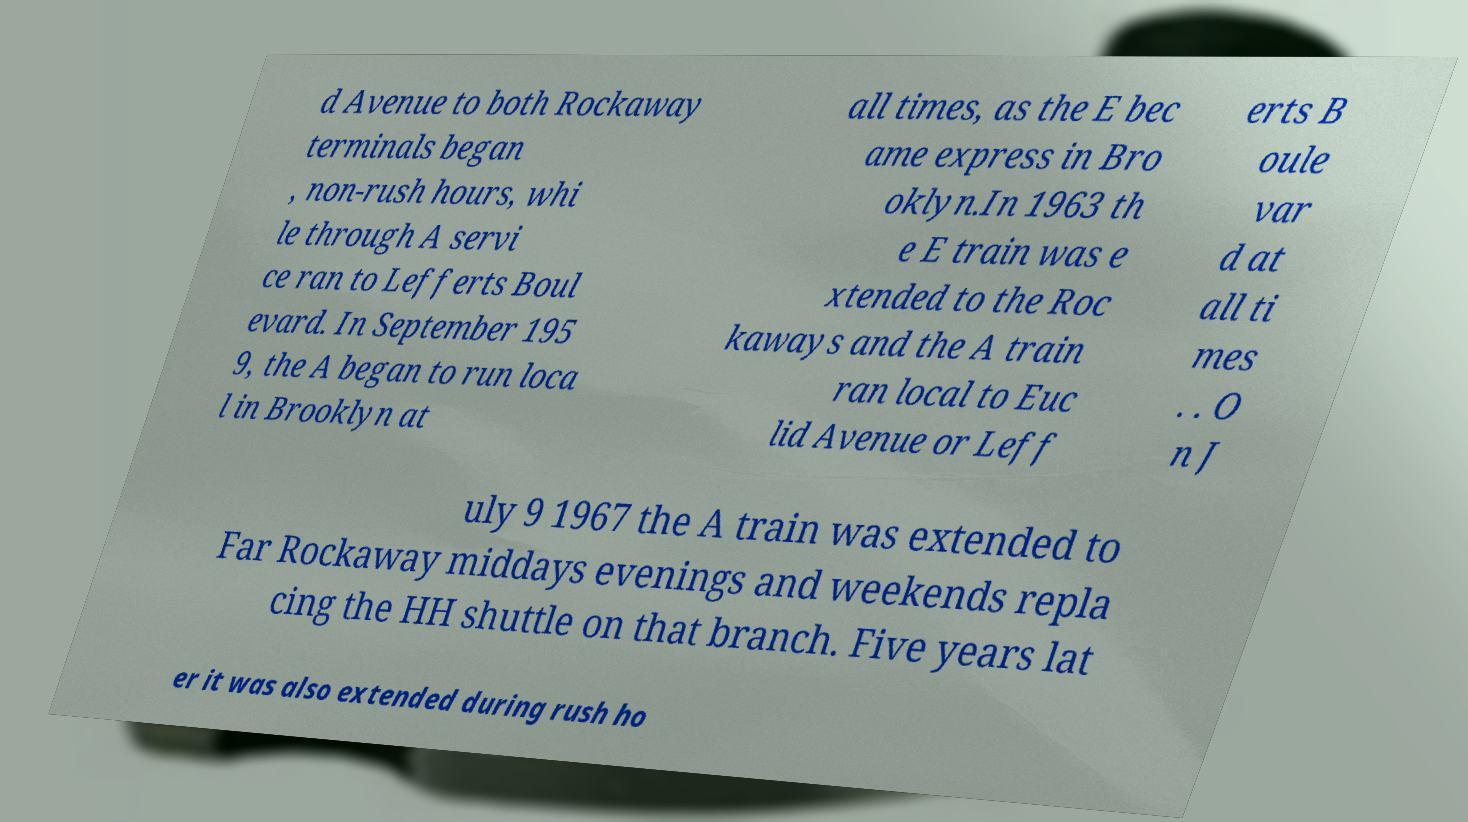Could you extract and type out the text from this image? d Avenue to both Rockaway terminals began , non-rush hours, whi le through A servi ce ran to Lefferts Boul evard. In September 195 9, the A began to run loca l in Brooklyn at all times, as the E bec ame express in Bro oklyn.In 1963 th e E train was e xtended to the Roc kaways and the A train ran local to Euc lid Avenue or Leff erts B oule var d at all ti mes . . O n J uly 9 1967 the A train was extended to Far Rockaway middays evenings and weekends repla cing the HH shuttle on that branch. Five years lat er it was also extended during rush ho 